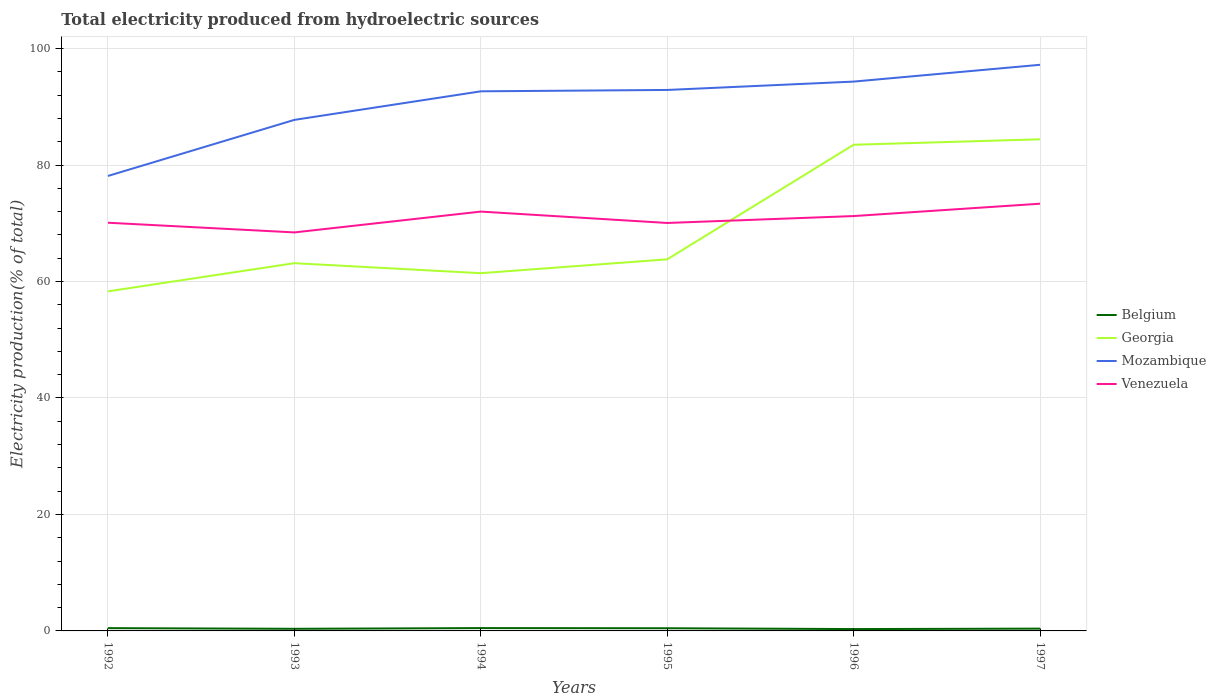Does the line corresponding to Mozambique intersect with the line corresponding to Belgium?
Make the answer very short. No. Across all years, what is the maximum total electricity produced in Mozambique?
Keep it short and to the point. 78.12. What is the total total electricity produced in Belgium in the graph?
Offer a terse response. 0.09. What is the difference between the highest and the second highest total electricity produced in Mozambique?
Give a very brief answer. 19.09. What is the difference between the highest and the lowest total electricity produced in Georgia?
Make the answer very short. 2. How many lines are there?
Offer a terse response. 4. What is the difference between two consecutive major ticks on the Y-axis?
Give a very brief answer. 20. Are the values on the major ticks of Y-axis written in scientific E-notation?
Offer a terse response. No. Where does the legend appear in the graph?
Give a very brief answer. Center right. How are the legend labels stacked?
Ensure brevity in your answer.  Vertical. What is the title of the graph?
Offer a terse response. Total electricity produced from hydroelectric sources. What is the label or title of the X-axis?
Keep it short and to the point. Years. What is the Electricity production(% of total) in Belgium in 1992?
Make the answer very short. 0.48. What is the Electricity production(% of total) of Georgia in 1992?
Offer a very short reply. 58.31. What is the Electricity production(% of total) of Mozambique in 1992?
Offer a very short reply. 78.12. What is the Electricity production(% of total) of Venezuela in 1992?
Give a very brief answer. 70.09. What is the Electricity production(% of total) of Belgium in 1993?
Offer a very short reply. 0.36. What is the Electricity production(% of total) in Georgia in 1993?
Your answer should be compact. 63.15. What is the Electricity production(% of total) of Mozambique in 1993?
Offer a very short reply. 87.76. What is the Electricity production(% of total) of Venezuela in 1993?
Provide a short and direct response. 68.43. What is the Electricity production(% of total) of Belgium in 1994?
Your answer should be compact. 0.48. What is the Electricity production(% of total) of Georgia in 1994?
Provide a short and direct response. 61.43. What is the Electricity production(% of total) of Mozambique in 1994?
Your answer should be compact. 92.66. What is the Electricity production(% of total) of Venezuela in 1994?
Ensure brevity in your answer.  72.01. What is the Electricity production(% of total) of Belgium in 1995?
Your response must be concise. 0.46. What is the Electricity production(% of total) of Georgia in 1995?
Ensure brevity in your answer.  63.81. What is the Electricity production(% of total) in Mozambique in 1995?
Give a very brief answer. 92.89. What is the Electricity production(% of total) in Venezuela in 1995?
Your answer should be compact. 70.05. What is the Electricity production(% of total) in Belgium in 1996?
Ensure brevity in your answer.  0.32. What is the Electricity production(% of total) in Georgia in 1996?
Keep it short and to the point. 83.48. What is the Electricity production(% of total) in Mozambique in 1996?
Your response must be concise. 94.33. What is the Electricity production(% of total) in Venezuela in 1996?
Give a very brief answer. 71.24. What is the Electricity production(% of total) of Belgium in 1997?
Your answer should be compact. 0.39. What is the Electricity production(% of total) of Georgia in 1997?
Your answer should be very brief. 84.42. What is the Electricity production(% of total) in Mozambique in 1997?
Make the answer very short. 97.21. What is the Electricity production(% of total) of Venezuela in 1997?
Provide a succinct answer. 73.36. Across all years, what is the maximum Electricity production(% of total) in Belgium?
Provide a succinct answer. 0.48. Across all years, what is the maximum Electricity production(% of total) in Georgia?
Offer a very short reply. 84.42. Across all years, what is the maximum Electricity production(% of total) of Mozambique?
Offer a very short reply. 97.21. Across all years, what is the maximum Electricity production(% of total) in Venezuela?
Your response must be concise. 73.36. Across all years, what is the minimum Electricity production(% of total) in Belgium?
Your response must be concise. 0.32. Across all years, what is the minimum Electricity production(% of total) in Georgia?
Provide a short and direct response. 58.31. Across all years, what is the minimum Electricity production(% of total) of Mozambique?
Make the answer very short. 78.12. Across all years, what is the minimum Electricity production(% of total) in Venezuela?
Give a very brief answer. 68.43. What is the total Electricity production(% of total) in Belgium in the graph?
Provide a short and direct response. 2.49. What is the total Electricity production(% of total) in Georgia in the graph?
Keep it short and to the point. 414.6. What is the total Electricity production(% of total) of Mozambique in the graph?
Give a very brief answer. 542.97. What is the total Electricity production(% of total) of Venezuela in the graph?
Provide a short and direct response. 425.18. What is the difference between the Electricity production(% of total) in Belgium in 1992 and that in 1993?
Provide a succinct answer. 0.12. What is the difference between the Electricity production(% of total) in Georgia in 1992 and that in 1993?
Provide a short and direct response. -4.84. What is the difference between the Electricity production(% of total) of Mozambique in 1992 and that in 1993?
Your response must be concise. -9.63. What is the difference between the Electricity production(% of total) in Venezuela in 1992 and that in 1993?
Make the answer very short. 1.66. What is the difference between the Electricity production(% of total) in Belgium in 1992 and that in 1994?
Ensure brevity in your answer.  -0.01. What is the difference between the Electricity production(% of total) in Georgia in 1992 and that in 1994?
Provide a short and direct response. -3.12. What is the difference between the Electricity production(% of total) of Mozambique in 1992 and that in 1994?
Provide a succinct answer. -14.53. What is the difference between the Electricity production(% of total) in Venezuela in 1992 and that in 1994?
Keep it short and to the point. -1.91. What is the difference between the Electricity production(% of total) in Belgium in 1992 and that in 1995?
Your answer should be compact. 0.02. What is the difference between the Electricity production(% of total) of Georgia in 1992 and that in 1995?
Offer a terse response. -5.5. What is the difference between the Electricity production(% of total) of Mozambique in 1992 and that in 1995?
Offer a terse response. -14.77. What is the difference between the Electricity production(% of total) of Venezuela in 1992 and that in 1995?
Offer a very short reply. 0.04. What is the difference between the Electricity production(% of total) in Belgium in 1992 and that in 1996?
Give a very brief answer. 0.16. What is the difference between the Electricity production(% of total) in Georgia in 1992 and that in 1996?
Your answer should be very brief. -25.17. What is the difference between the Electricity production(% of total) in Mozambique in 1992 and that in 1996?
Your response must be concise. -16.2. What is the difference between the Electricity production(% of total) in Venezuela in 1992 and that in 1996?
Your response must be concise. -1.14. What is the difference between the Electricity production(% of total) in Belgium in 1992 and that in 1997?
Your response must be concise. 0.09. What is the difference between the Electricity production(% of total) in Georgia in 1992 and that in 1997?
Offer a very short reply. -26.11. What is the difference between the Electricity production(% of total) in Mozambique in 1992 and that in 1997?
Your answer should be very brief. -19.09. What is the difference between the Electricity production(% of total) in Venezuela in 1992 and that in 1997?
Offer a terse response. -3.27. What is the difference between the Electricity production(% of total) of Belgium in 1993 and that in 1994?
Keep it short and to the point. -0.12. What is the difference between the Electricity production(% of total) in Georgia in 1993 and that in 1994?
Your answer should be very brief. 1.72. What is the difference between the Electricity production(% of total) of Mozambique in 1993 and that in 1994?
Your answer should be very brief. -4.9. What is the difference between the Electricity production(% of total) of Venezuela in 1993 and that in 1994?
Offer a very short reply. -3.58. What is the difference between the Electricity production(% of total) of Belgium in 1993 and that in 1995?
Provide a succinct answer. -0.1. What is the difference between the Electricity production(% of total) in Georgia in 1993 and that in 1995?
Give a very brief answer. -0.66. What is the difference between the Electricity production(% of total) in Mozambique in 1993 and that in 1995?
Offer a very short reply. -5.14. What is the difference between the Electricity production(% of total) of Venezuela in 1993 and that in 1995?
Your answer should be compact. -1.62. What is the difference between the Electricity production(% of total) in Belgium in 1993 and that in 1996?
Provide a short and direct response. 0.04. What is the difference between the Electricity production(% of total) in Georgia in 1993 and that in 1996?
Provide a short and direct response. -20.34. What is the difference between the Electricity production(% of total) in Mozambique in 1993 and that in 1996?
Your answer should be very brief. -6.57. What is the difference between the Electricity production(% of total) in Venezuela in 1993 and that in 1996?
Provide a succinct answer. -2.81. What is the difference between the Electricity production(% of total) in Belgium in 1993 and that in 1997?
Your response must be concise. -0.03. What is the difference between the Electricity production(% of total) in Georgia in 1993 and that in 1997?
Your answer should be very brief. -21.27. What is the difference between the Electricity production(% of total) in Mozambique in 1993 and that in 1997?
Give a very brief answer. -9.46. What is the difference between the Electricity production(% of total) of Venezuela in 1993 and that in 1997?
Give a very brief answer. -4.93. What is the difference between the Electricity production(% of total) of Belgium in 1994 and that in 1995?
Offer a very short reply. 0.03. What is the difference between the Electricity production(% of total) of Georgia in 1994 and that in 1995?
Your response must be concise. -2.38. What is the difference between the Electricity production(% of total) in Mozambique in 1994 and that in 1995?
Make the answer very short. -0.23. What is the difference between the Electricity production(% of total) of Venezuela in 1994 and that in 1995?
Your answer should be very brief. 1.96. What is the difference between the Electricity production(% of total) of Belgium in 1994 and that in 1996?
Your answer should be compact. 0.17. What is the difference between the Electricity production(% of total) in Georgia in 1994 and that in 1996?
Give a very brief answer. -22.05. What is the difference between the Electricity production(% of total) of Mozambique in 1994 and that in 1996?
Your answer should be compact. -1.67. What is the difference between the Electricity production(% of total) of Venezuela in 1994 and that in 1996?
Your answer should be very brief. 0.77. What is the difference between the Electricity production(% of total) in Belgium in 1994 and that in 1997?
Your answer should be compact. 0.09. What is the difference between the Electricity production(% of total) in Georgia in 1994 and that in 1997?
Keep it short and to the point. -22.99. What is the difference between the Electricity production(% of total) in Mozambique in 1994 and that in 1997?
Provide a short and direct response. -4.56. What is the difference between the Electricity production(% of total) in Venezuela in 1994 and that in 1997?
Offer a terse response. -1.35. What is the difference between the Electricity production(% of total) of Belgium in 1995 and that in 1996?
Provide a short and direct response. 0.14. What is the difference between the Electricity production(% of total) in Georgia in 1995 and that in 1996?
Offer a terse response. -19.67. What is the difference between the Electricity production(% of total) in Mozambique in 1995 and that in 1996?
Offer a very short reply. -1.44. What is the difference between the Electricity production(% of total) in Venezuela in 1995 and that in 1996?
Your answer should be very brief. -1.19. What is the difference between the Electricity production(% of total) of Belgium in 1995 and that in 1997?
Ensure brevity in your answer.  0.07. What is the difference between the Electricity production(% of total) of Georgia in 1995 and that in 1997?
Provide a short and direct response. -20.61. What is the difference between the Electricity production(% of total) in Mozambique in 1995 and that in 1997?
Offer a terse response. -4.32. What is the difference between the Electricity production(% of total) in Venezuela in 1995 and that in 1997?
Provide a short and direct response. -3.31. What is the difference between the Electricity production(% of total) in Belgium in 1996 and that in 1997?
Make the answer very short. -0.07. What is the difference between the Electricity production(% of total) of Georgia in 1996 and that in 1997?
Provide a succinct answer. -0.94. What is the difference between the Electricity production(% of total) of Mozambique in 1996 and that in 1997?
Your answer should be compact. -2.89. What is the difference between the Electricity production(% of total) of Venezuela in 1996 and that in 1997?
Provide a short and direct response. -2.12. What is the difference between the Electricity production(% of total) of Belgium in 1992 and the Electricity production(% of total) of Georgia in 1993?
Your response must be concise. -62.67. What is the difference between the Electricity production(% of total) of Belgium in 1992 and the Electricity production(% of total) of Mozambique in 1993?
Provide a succinct answer. -87.28. What is the difference between the Electricity production(% of total) in Belgium in 1992 and the Electricity production(% of total) in Venezuela in 1993?
Make the answer very short. -67.95. What is the difference between the Electricity production(% of total) in Georgia in 1992 and the Electricity production(% of total) in Mozambique in 1993?
Your answer should be very brief. -29.44. What is the difference between the Electricity production(% of total) in Georgia in 1992 and the Electricity production(% of total) in Venezuela in 1993?
Provide a succinct answer. -10.12. What is the difference between the Electricity production(% of total) in Mozambique in 1992 and the Electricity production(% of total) in Venezuela in 1993?
Provide a succinct answer. 9.7. What is the difference between the Electricity production(% of total) in Belgium in 1992 and the Electricity production(% of total) in Georgia in 1994?
Offer a terse response. -60.95. What is the difference between the Electricity production(% of total) of Belgium in 1992 and the Electricity production(% of total) of Mozambique in 1994?
Offer a terse response. -92.18. What is the difference between the Electricity production(% of total) of Belgium in 1992 and the Electricity production(% of total) of Venezuela in 1994?
Offer a very short reply. -71.53. What is the difference between the Electricity production(% of total) of Georgia in 1992 and the Electricity production(% of total) of Mozambique in 1994?
Give a very brief answer. -34.35. What is the difference between the Electricity production(% of total) in Georgia in 1992 and the Electricity production(% of total) in Venezuela in 1994?
Your answer should be very brief. -13.7. What is the difference between the Electricity production(% of total) in Mozambique in 1992 and the Electricity production(% of total) in Venezuela in 1994?
Give a very brief answer. 6.12. What is the difference between the Electricity production(% of total) in Belgium in 1992 and the Electricity production(% of total) in Georgia in 1995?
Keep it short and to the point. -63.33. What is the difference between the Electricity production(% of total) of Belgium in 1992 and the Electricity production(% of total) of Mozambique in 1995?
Your response must be concise. -92.41. What is the difference between the Electricity production(% of total) in Belgium in 1992 and the Electricity production(% of total) in Venezuela in 1995?
Your response must be concise. -69.57. What is the difference between the Electricity production(% of total) in Georgia in 1992 and the Electricity production(% of total) in Mozambique in 1995?
Give a very brief answer. -34.58. What is the difference between the Electricity production(% of total) of Georgia in 1992 and the Electricity production(% of total) of Venezuela in 1995?
Provide a succinct answer. -11.74. What is the difference between the Electricity production(% of total) of Mozambique in 1992 and the Electricity production(% of total) of Venezuela in 1995?
Offer a very short reply. 8.07. What is the difference between the Electricity production(% of total) in Belgium in 1992 and the Electricity production(% of total) in Georgia in 1996?
Provide a succinct answer. -83.01. What is the difference between the Electricity production(% of total) of Belgium in 1992 and the Electricity production(% of total) of Mozambique in 1996?
Make the answer very short. -93.85. What is the difference between the Electricity production(% of total) in Belgium in 1992 and the Electricity production(% of total) in Venezuela in 1996?
Ensure brevity in your answer.  -70.76. What is the difference between the Electricity production(% of total) of Georgia in 1992 and the Electricity production(% of total) of Mozambique in 1996?
Offer a terse response. -36.02. What is the difference between the Electricity production(% of total) of Georgia in 1992 and the Electricity production(% of total) of Venezuela in 1996?
Ensure brevity in your answer.  -12.93. What is the difference between the Electricity production(% of total) of Mozambique in 1992 and the Electricity production(% of total) of Venezuela in 1996?
Your answer should be very brief. 6.89. What is the difference between the Electricity production(% of total) in Belgium in 1992 and the Electricity production(% of total) in Georgia in 1997?
Keep it short and to the point. -83.94. What is the difference between the Electricity production(% of total) in Belgium in 1992 and the Electricity production(% of total) in Mozambique in 1997?
Ensure brevity in your answer.  -96.74. What is the difference between the Electricity production(% of total) of Belgium in 1992 and the Electricity production(% of total) of Venezuela in 1997?
Offer a terse response. -72.88. What is the difference between the Electricity production(% of total) in Georgia in 1992 and the Electricity production(% of total) in Mozambique in 1997?
Your answer should be very brief. -38.9. What is the difference between the Electricity production(% of total) of Georgia in 1992 and the Electricity production(% of total) of Venezuela in 1997?
Provide a short and direct response. -15.05. What is the difference between the Electricity production(% of total) in Mozambique in 1992 and the Electricity production(% of total) in Venezuela in 1997?
Keep it short and to the point. 4.77. What is the difference between the Electricity production(% of total) of Belgium in 1993 and the Electricity production(% of total) of Georgia in 1994?
Your answer should be very brief. -61.07. What is the difference between the Electricity production(% of total) of Belgium in 1993 and the Electricity production(% of total) of Mozambique in 1994?
Your answer should be very brief. -92.3. What is the difference between the Electricity production(% of total) in Belgium in 1993 and the Electricity production(% of total) in Venezuela in 1994?
Offer a terse response. -71.64. What is the difference between the Electricity production(% of total) in Georgia in 1993 and the Electricity production(% of total) in Mozambique in 1994?
Your answer should be compact. -29.51. What is the difference between the Electricity production(% of total) of Georgia in 1993 and the Electricity production(% of total) of Venezuela in 1994?
Offer a terse response. -8.86. What is the difference between the Electricity production(% of total) in Mozambique in 1993 and the Electricity production(% of total) in Venezuela in 1994?
Your response must be concise. 15.75. What is the difference between the Electricity production(% of total) in Belgium in 1993 and the Electricity production(% of total) in Georgia in 1995?
Offer a very short reply. -63.45. What is the difference between the Electricity production(% of total) of Belgium in 1993 and the Electricity production(% of total) of Mozambique in 1995?
Provide a succinct answer. -92.53. What is the difference between the Electricity production(% of total) in Belgium in 1993 and the Electricity production(% of total) in Venezuela in 1995?
Provide a short and direct response. -69.69. What is the difference between the Electricity production(% of total) in Georgia in 1993 and the Electricity production(% of total) in Mozambique in 1995?
Offer a terse response. -29.75. What is the difference between the Electricity production(% of total) in Georgia in 1993 and the Electricity production(% of total) in Venezuela in 1995?
Provide a succinct answer. -6.9. What is the difference between the Electricity production(% of total) in Mozambique in 1993 and the Electricity production(% of total) in Venezuela in 1995?
Your response must be concise. 17.7. What is the difference between the Electricity production(% of total) of Belgium in 1993 and the Electricity production(% of total) of Georgia in 1996?
Your answer should be compact. -83.12. What is the difference between the Electricity production(% of total) in Belgium in 1993 and the Electricity production(% of total) in Mozambique in 1996?
Provide a short and direct response. -93.97. What is the difference between the Electricity production(% of total) in Belgium in 1993 and the Electricity production(% of total) in Venezuela in 1996?
Ensure brevity in your answer.  -70.88. What is the difference between the Electricity production(% of total) in Georgia in 1993 and the Electricity production(% of total) in Mozambique in 1996?
Ensure brevity in your answer.  -31.18. What is the difference between the Electricity production(% of total) in Georgia in 1993 and the Electricity production(% of total) in Venezuela in 1996?
Your answer should be very brief. -8.09. What is the difference between the Electricity production(% of total) of Mozambique in 1993 and the Electricity production(% of total) of Venezuela in 1996?
Ensure brevity in your answer.  16.52. What is the difference between the Electricity production(% of total) of Belgium in 1993 and the Electricity production(% of total) of Georgia in 1997?
Keep it short and to the point. -84.06. What is the difference between the Electricity production(% of total) in Belgium in 1993 and the Electricity production(% of total) in Mozambique in 1997?
Ensure brevity in your answer.  -96.85. What is the difference between the Electricity production(% of total) of Belgium in 1993 and the Electricity production(% of total) of Venezuela in 1997?
Your response must be concise. -73. What is the difference between the Electricity production(% of total) in Georgia in 1993 and the Electricity production(% of total) in Mozambique in 1997?
Offer a terse response. -34.07. What is the difference between the Electricity production(% of total) in Georgia in 1993 and the Electricity production(% of total) in Venezuela in 1997?
Your response must be concise. -10.21. What is the difference between the Electricity production(% of total) in Mozambique in 1993 and the Electricity production(% of total) in Venezuela in 1997?
Ensure brevity in your answer.  14.4. What is the difference between the Electricity production(% of total) in Belgium in 1994 and the Electricity production(% of total) in Georgia in 1995?
Your answer should be very brief. -63.32. What is the difference between the Electricity production(% of total) of Belgium in 1994 and the Electricity production(% of total) of Mozambique in 1995?
Your response must be concise. -92.41. What is the difference between the Electricity production(% of total) of Belgium in 1994 and the Electricity production(% of total) of Venezuela in 1995?
Give a very brief answer. -69.57. What is the difference between the Electricity production(% of total) in Georgia in 1994 and the Electricity production(% of total) in Mozambique in 1995?
Provide a short and direct response. -31.46. What is the difference between the Electricity production(% of total) of Georgia in 1994 and the Electricity production(% of total) of Venezuela in 1995?
Make the answer very short. -8.62. What is the difference between the Electricity production(% of total) in Mozambique in 1994 and the Electricity production(% of total) in Venezuela in 1995?
Provide a short and direct response. 22.61. What is the difference between the Electricity production(% of total) of Belgium in 1994 and the Electricity production(% of total) of Georgia in 1996?
Your answer should be compact. -83. What is the difference between the Electricity production(% of total) in Belgium in 1994 and the Electricity production(% of total) in Mozambique in 1996?
Provide a short and direct response. -93.84. What is the difference between the Electricity production(% of total) of Belgium in 1994 and the Electricity production(% of total) of Venezuela in 1996?
Ensure brevity in your answer.  -70.75. What is the difference between the Electricity production(% of total) of Georgia in 1994 and the Electricity production(% of total) of Mozambique in 1996?
Make the answer very short. -32.9. What is the difference between the Electricity production(% of total) in Georgia in 1994 and the Electricity production(% of total) in Venezuela in 1996?
Offer a terse response. -9.81. What is the difference between the Electricity production(% of total) in Mozambique in 1994 and the Electricity production(% of total) in Venezuela in 1996?
Make the answer very short. 21.42. What is the difference between the Electricity production(% of total) of Belgium in 1994 and the Electricity production(% of total) of Georgia in 1997?
Ensure brevity in your answer.  -83.93. What is the difference between the Electricity production(% of total) in Belgium in 1994 and the Electricity production(% of total) in Mozambique in 1997?
Ensure brevity in your answer.  -96.73. What is the difference between the Electricity production(% of total) of Belgium in 1994 and the Electricity production(% of total) of Venezuela in 1997?
Give a very brief answer. -72.87. What is the difference between the Electricity production(% of total) in Georgia in 1994 and the Electricity production(% of total) in Mozambique in 1997?
Provide a succinct answer. -35.78. What is the difference between the Electricity production(% of total) of Georgia in 1994 and the Electricity production(% of total) of Venezuela in 1997?
Keep it short and to the point. -11.93. What is the difference between the Electricity production(% of total) in Mozambique in 1994 and the Electricity production(% of total) in Venezuela in 1997?
Offer a terse response. 19.3. What is the difference between the Electricity production(% of total) of Belgium in 1995 and the Electricity production(% of total) of Georgia in 1996?
Offer a very short reply. -83.02. What is the difference between the Electricity production(% of total) in Belgium in 1995 and the Electricity production(% of total) in Mozambique in 1996?
Offer a terse response. -93.87. What is the difference between the Electricity production(% of total) in Belgium in 1995 and the Electricity production(% of total) in Venezuela in 1996?
Your response must be concise. -70.78. What is the difference between the Electricity production(% of total) in Georgia in 1995 and the Electricity production(% of total) in Mozambique in 1996?
Give a very brief answer. -30.52. What is the difference between the Electricity production(% of total) in Georgia in 1995 and the Electricity production(% of total) in Venezuela in 1996?
Your answer should be very brief. -7.43. What is the difference between the Electricity production(% of total) in Mozambique in 1995 and the Electricity production(% of total) in Venezuela in 1996?
Keep it short and to the point. 21.65. What is the difference between the Electricity production(% of total) in Belgium in 1995 and the Electricity production(% of total) in Georgia in 1997?
Make the answer very short. -83.96. What is the difference between the Electricity production(% of total) in Belgium in 1995 and the Electricity production(% of total) in Mozambique in 1997?
Your answer should be very brief. -96.75. What is the difference between the Electricity production(% of total) in Belgium in 1995 and the Electricity production(% of total) in Venezuela in 1997?
Offer a very short reply. -72.9. What is the difference between the Electricity production(% of total) in Georgia in 1995 and the Electricity production(% of total) in Mozambique in 1997?
Provide a succinct answer. -33.4. What is the difference between the Electricity production(% of total) in Georgia in 1995 and the Electricity production(% of total) in Venezuela in 1997?
Your answer should be very brief. -9.55. What is the difference between the Electricity production(% of total) in Mozambique in 1995 and the Electricity production(% of total) in Venezuela in 1997?
Offer a very short reply. 19.53. What is the difference between the Electricity production(% of total) in Belgium in 1996 and the Electricity production(% of total) in Georgia in 1997?
Provide a short and direct response. -84.1. What is the difference between the Electricity production(% of total) of Belgium in 1996 and the Electricity production(% of total) of Mozambique in 1997?
Keep it short and to the point. -96.9. What is the difference between the Electricity production(% of total) of Belgium in 1996 and the Electricity production(% of total) of Venezuela in 1997?
Give a very brief answer. -73.04. What is the difference between the Electricity production(% of total) of Georgia in 1996 and the Electricity production(% of total) of Mozambique in 1997?
Ensure brevity in your answer.  -13.73. What is the difference between the Electricity production(% of total) in Georgia in 1996 and the Electricity production(% of total) in Venezuela in 1997?
Your response must be concise. 10.12. What is the difference between the Electricity production(% of total) in Mozambique in 1996 and the Electricity production(% of total) in Venezuela in 1997?
Ensure brevity in your answer.  20.97. What is the average Electricity production(% of total) of Belgium per year?
Provide a short and direct response. 0.42. What is the average Electricity production(% of total) in Georgia per year?
Offer a very short reply. 69.1. What is the average Electricity production(% of total) in Mozambique per year?
Keep it short and to the point. 90.5. What is the average Electricity production(% of total) of Venezuela per year?
Ensure brevity in your answer.  70.86. In the year 1992, what is the difference between the Electricity production(% of total) of Belgium and Electricity production(% of total) of Georgia?
Make the answer very short. -57.83. In the year 1992, what is the difference between the Electricity production(% of total) of Belgium and Electricity production(% of total) of Mozambique?
Give a very brief answer. -77.65. In the year 1992, what is the difference between the Electricity production(% of total) in Belgium and Electricity production(% of total) in Venezuela?
Give a very brief answer. -69.62. In the year 1992, what is the difference between the Electricity production(% of total) in Georgia and Electricity production(% of total) in Mozambique?
Offer a very short reply. -19.81. In the year 1992, what is the difference between the Electricity production(% of total) in Georgia and Electricity production(% of total) in Venezuela?
Your answer should be very brief. -11.78. In the year 1992, what is the difference between the Electricity production(% of total) of Mozambique and Electricity production(% of total) of Venezuela?
Make the answer very short. 8.03. In the year 1993, what is the difference between the Electricity production(% of total) of Belgium and Electricity production(% of total) of Georgia?
Offer a terse response. -62.78. In the year 1993, what is the difference between the Electricity production(% of total) of Belgium and Electricity production(% of total) of Mozambique?
Ensure brevity in your answer.  -87.39. In the year 1993, what is the difference between the Electricity production(% of total) of Belgium and Electricity production(% of total) of Venezuela?
Make the answer very short. -68.07. In the year 1993, what is the difference between the Electricity production(% of total) in Georgia and Electricity production(% of total) in Mozambique?
Provide a short and direct response. -24.61. In the year 1993, what is the difference between the Electricity production(% of total) in Georgia and Electricity production(% of total) in Venezuela?
Provide a short and direct response. -5.28. In the year 1993, what is the difference between the Electricity production(% of total) of Mozambique and Electricity production(% of total) of Venezuela?
Your answer should be very brief. 19.33. In the year 1994, what is the difference between the Electricity production(% of total) of Belgium and Electricity production(% of total) of Georgia?
Keep it short and to the point. -60.94. In the year 1994, what is the difference between the Electricity production(% of total) of Belgium and Electricity production(% of total) of Mozambique?
Keep it short and to the point. -92.17. In the year 1994, what is the difference between the Electricity production(% of total) in Belgium and Electricity production(% of total) in Venezuela?
Your answer should be compact. -71.52. In the year 1994, what is the difference between the Electricity production(% of total) in Georgia and Electricity production(% of total) in Mozambique?
Ensure brevity in your answer.  -31.23. In the year 1994, what is the difference between the Electricity production(% of total) in Georgia and Electricity production(% of total) in Venezuela?
Offer a terse response. -10.58. In the year 1994, what is the difference between the Electricity production(% of total) of Mozambique and Electricity production(% of total) of Venezuela?
Provide a short and direct response. 20.65. In the year 1995, what is the difference between the Electricity production(% of total) in Belgium and Electricity production(% of total) in Georgia?
Provide a succinct answer. -63.35. In the year 1995, what is the difference between the Electricity production(% of total) in Belgium and Electricity production(% of total) in Mozambique?
Offer a terse response. -92.43. In the year 1995, what is the difference between the Electricity production(% of total) in Belgium and Electricity production(% of total) in Venezuela?
Provide a short and direct response. -69.59. In the year 1995, what is the difference between the Electricity production(% of total) of Georgia and Electricity production(% of total) of Mozambique?
Your answer should be very brief. -29.08. In the year 1995, what is the difference between the Electricity production(% of total) of Georgia and Electricity production(% of total) of Venezuela?
Ensure brevity in your answer.  -6.24. In the year 1995, what is the difference between the Electricity production(% of total) in Mozambique and Electricity production(% of total) in Venezuela?
Give a very brief answer. 22.84. In the year 1996, what is the difference between the Electricity production(% of total) of Belgium and Electricity production(% of total) of Georgia?
Your answer should be compact. -83.17. In the year 1996, what is the difference between the Electricity production(% of total) in Belgium and Electricity production(% of total) in Mozambique?
Offer a terse response. -94.01. In the year 1996, what is the difference between the Electricity production(% of total) of Belgium and Electricity production(% of total) of Venezuela?
Offer a terse response. -70.92. In the year 1996, what is the difference between the Electricity production(% of total) in Georgia and Electricity production(% of total) in Mozambique?
Your answer should be very brief. -10.84. In the year 1996, what is the difference between the Electricity production(% of total) in Georgia and Electricity production(% of total) in Venezuela?
Your response must be concise. 12.25. In the year 1996, what is the difference between the Electricity production(% of total) in Mozambique and Electricity production(% of total) in Venezuela?
Keep it short and to the point. 23.09. In the year 1997, what is the difference between the Electricity production(% of total) of Belgium and Electricity production(% of total) of Georgia?
Ensure brevity in your answer.  -84.03. In the year 1997, what is the difference between the Electricity production(% of total) in Belgium and Electricity production(% of total) in Mozambique?
Give a very brief answer. -96.82. In the year 1997, what is the difference between the Electricity production(% of total) in Belgium and Electricity production(% of total) in Venezuela?
Offer a very short reply. -72.97. In the year 1997, what is the difference between the Electricity production(% of total) in Georgia and Electricity production(% of total) in Mozambique?
Make the answer very short. -12.79. In the year 1997, what is the difference between the Electricity production(% of total) in Georgia and Electricity production(% of total) in Venezuela?
Provide a succinct answer. 11.06. In the year 1997, what is the difference between the Electricity production(% of total) of Mozambique and Electricity production(% of total) of Venezuela?
Make the answer very short. 23.85. What is the ratio of the Electricity production(% of total) of Belgium in 1992 to that in 1993?
Offer a very short reply. 1.32. What is the ratio of the Electricity production(% of total) in Georgia in 1992 to that in 1993?
Provide a short and direct response. 0.92. What is the ratio of the Electricity production(% of total) of Mozambique in 1992 to that in 1993?
Provide a succinct answer. 0.89. What is the ratio of the Electricity production(% of total) in Venezuela in 1992 to that in 1993?
Your answer should be compact. 1.02. What is the ratio of the Electricity production(% of total) in Belgium in 1992 to that in 1994?
Offer a terse response. 0.98. What is the ratio of the Electricity production(% of total) of Georgia in 1992 to that in 1994?
Your answer should be very brief. 0.95. What is the ratio of the Electricity production(% of total) of Mozambique in 1992 to that in 1994?
Ensure brevity in your answer.  0.84. What is the ratio of the Electricity production(% of total) of Venezuela in 1992 to that in 1994?
Your answer should be compact. 0.97. What is the ratio of the Electricity production(% of total) of Belgium in 1992 to that in 1995?
Provide a succinct answer. 1.04. What is the ratio of the Electricity production(% of total) in Georgia in 1992 to that in 1995?
Offer a terse response. 0.91. What is the ratio of the Electricity production(% of total) in Mozambique in 1992 to that in 1995?
Provide a succinct answer. 0.84. What is the ratio of the Electricity production(% of total) in Venezuela in 1992 to that in 1995?
Provide a succinct answer. 1. What is the ratio of the Electricity production(% of total) of Belgium in 1992 to that in 1996?
Make the answer very short. 1.5. What is the ratio of the Electricity production(% of total) of Georgia in 1992 to that in 1996?
Provide a short and direct response. 0.7. What is the ratio of the Electricity production(% of total) in Mozambique in 1992 to that in 1996?
Ensure brevity in your answer.  0.83. What is the ratio of the Electricity production(% of total) of Venezuela in 1992 to that in 1996?
Ensure brevity in your answer.  0.98. What is the ratio of the Electricity production(% of total) of Belgium in 1992 to that in 1997?
Your answer should be compact. 1.22. What is the ratio of the Electricity production(% of total) in Georgia in 1992 to that in 1997?
Your response must be concise. 0.69. What is the ratio of the Electricity production(% of total) in Mozambique in 1992 to that in 1997?
Provide a short and direct response. 0.8. What is the ratio of the Electricity production(% of total) of Venezuela in 1992 to that in 1997?
Keep it short and to the point. 0.96. What is the ratio of the Electricity production(% of total) in Belgium in 1993 to that in 1994?
Offer a very short reply. 0.75. What is the ratio of the Electricity production(% of total) of Georgia in 1993 to that in 1994?
Keep it short and to the point. 1.03. What is the ratio of the Electricity production(% of total) in Mozambique in 1993 to that in 1994?
Offer a very short reply. 0.95. What is the ratio of the Electricity production(% of total) in Venezuela in 1993 to that in 1994?
Offer a terse response. 0.95. What is the ratio of the Electricity production(% of total) of Belgium in 1993 to that in 1995?
Keep it short and to the point. 0.79. What is the ratio of the Electricity production(% of total) of Mozambique in 1993 to that in 1995?
Provide a succinct answer. 0.94. What is the ratio of the Electricity production(% of total) in Venezuela in 1993 to that in 1995?
Offer a terse response. 0.98. What is the ratio of the Electricity production(% of total) in Belgium in 1993 to that in 1996?
Make the answer very short. 1.14. What is the ratio of the Electricity production(% of total) in Georgia in 1993 to that in 1996?
Offer a very short reply. 0.76. What is the ratio of the Electricity production(% of total) of Mozambique in 1993 to that in 1996?
Offer a very short reply. 0.93. What is the ratio of the Electricity production(% of total) in Venezuela in 1993 to that in 1996?
Offer a very short reply. 0.96. What is the ratio of the Electricity production(% of total) of Belgium in 1993 to that in 1997?
Keep it short and to the point. 0.93. What is the ratio of the Electricity production(% of total) in Georgia in 1993 to that in 1997?
Your answer should be very brief. 0.75. What is the ratio of the Electricity production(% of total) of Mozambique in 1993 to that in 1997?
Provide a succinct answer. 0.9. What is the ratio of the Electricity production(% of total) in Venezuela in 1993 to that in 1997?
Keep it short and to the point. 0.93. What is the ratio of the Electricity production(% of total) in Belgium in 1994 to that in 1995?
Your response must be concise. 1.05. What is the ratio of the Electricity production(% of total) of Georgia in 1994 to that in 1995?
Keep it short and to the point. 0.96. What is the ratio of the Electricity production(% of total) in Mozambique in 1994 to that in 1995?
Provide a succinct answer. 1. What is the ratio of the Electricity production(% of total) in Venezuela in 1994 to that in 1995?
Give a very brief answer. 1.03. What is the ratio of the Electricity production(% of total) in Belgium in 1994 to that in 1996?
Your response must be concise. 1.52. What is the ratio of the Electricity production(% of total) in Georgia in 1994 to that in 1996?
Your answer should be very brief. 0.74. What is the ratio of the Electricity production(% of total) in Mozambique in 1994 to that in 1996?
Provide a short and direct response. 0.98. What is the ratio of the Electricity production(% of total) in Venezuela in 1994 to that in 1996?
Your response must be concise. 1.01. What is the ratio of the Electricity production(% of total) of Belgium in 1994 to that in 1997?
Your answer should be compact. 1.24. What is the ratio of the Electricity production(% of total) in Georgia in 1994 to that in 1997?
Provide a succinct answer. 0.73. What is the ratio of the Electricity production(% of total) of Mozambique in 1994 to that in 1997?
Offer a very short reply. 0.95. What is the ratio of the Electricity production(% of total) of Venezuela in 1994 to that in 1997?
Your answer should be compact. 0.98. What is the ratio of the Electricity production(% of total) of Belgium in 1995 to that in 1996?
Make the answer very short. 1.45. What is the ratio of the Electricity production(% of total) in Georgia in 1995 to that in 1996?
Give a very brief answer. 0.76. What is the ratio of the Electricity production(% of total) in Venezuela in 1995 to that in 1996?
Offer a very short reply. 0.98. What is the ratio of the Electricity production(% of total) in Belgium in 1995 to that in 1997?
Give a very brief answer. 1.17. What is the ratio of the Electricity production(% of total) in Georgia in 1995 to that in 1997?
Ensure brevity in your answer.  0.76. What is the ratio of the Electricity production(% of total) of Mozambique in 1995 to that in 1997?
Your response must be concise. 0.96. What is the ratio of the Electricity production(% of total) of Venezuela in 1995 to that in 1997?
Your answer should be compact. 0.95. What is the ratio of the Electricity production(% of total) of Belgium in 1996 to that in 1997?
Give a very brief answer. 0.81. What is the ratio of the Electricity production(% of total) of Georgia in 1996 to that in 1997?
Offer a very short reply. 0.99. What is the ratio of the Electricity production(% of total) of Mozambique in 1996 to that in 1997?
Provide a succinct answer. 0.97. What is the ratio of the Electricity production(% of total) of Venezuela in 1996 to that in 1997?
Your response must be concise. 0.97. What is the difference between the highest and the second highest Electricity production(% of total) in Belgium?
Your answer should be compact. 0.01. What is the difference between the highest and the second highest Electricity production(% of total) in Georgia?
Your response must be concise. 0.94. What is the difference between the highest and the second highest Electricity production(% of total) in Mozambique?
Provide a succinct answer. 2.89. What is the difference between the highest and the second highest Electricity production(% of total) of Venezuela?
Offer a very short reply. 1.35. What is the difference between the highest and the lowest Electricity production(% of total) of Belgium?
Offer a terse response. 0.17. What is the difference between the highest and the lowest Electricity production(% of total) of Georgia?
Your answer should be very brief. 26.11. What is the difference between the highest and the lowest Electricity production(% of total) in Mozambique?
Make the answer very short. 19.09. What is the difference between the highest and the lowest Electricity production(% of total) in Venezuela?
Your answer should be compact. 4.93. 